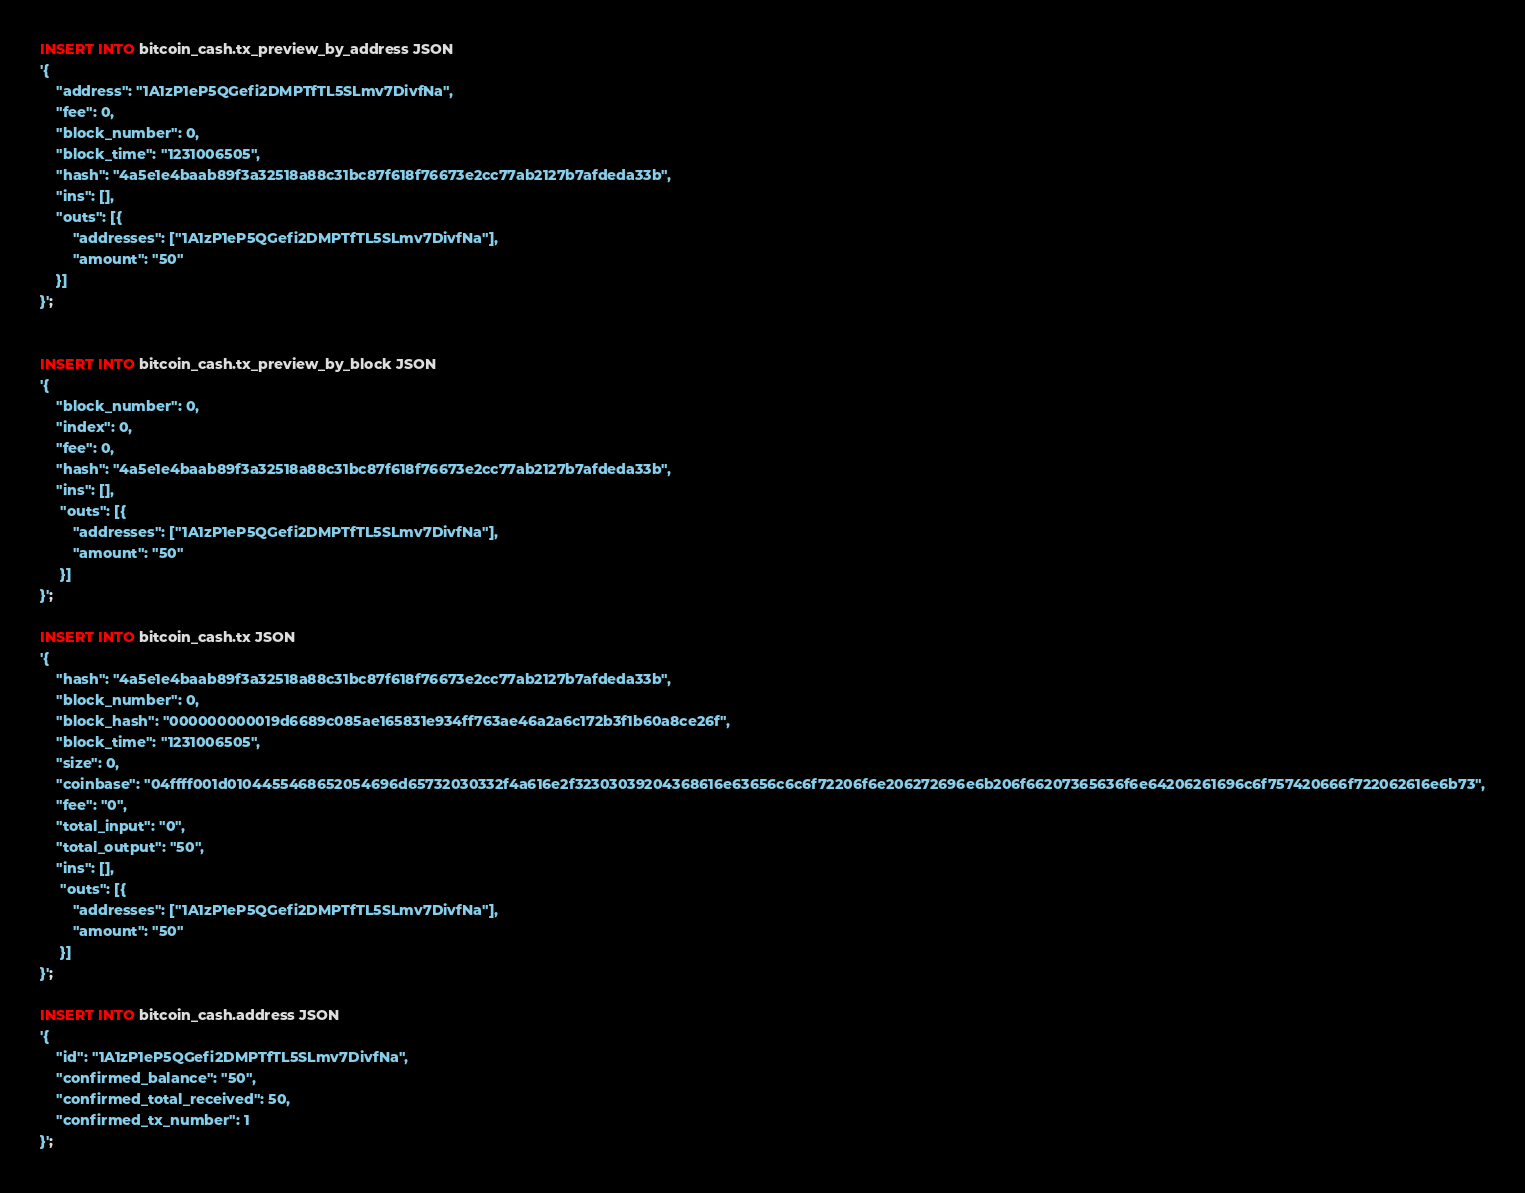Convert code to text. <code><loc_0><loc_0><loc_500><loc_500><_SQL_>INSERT INTO bitcoin_cash.tx_preview_by_address JSON
'{
    "address": "1A1zP1eP5QGefi2DMPTfTL5SLmv7DivfNa",
    "fee": 0,
    "block_number": 0,
    "block_time": "1231006505",
    "hash": "4a5e1e4baab89f3a32518a88c31bc87f618f76673e2cc77ab2127b7afdeda33b",
    "ins": [],
    "outs": [{
        "addresses": ["1A1zP1eP5QGefi2DMPTfTL5SLmv7DivfNa"],
        "amount": "50"
    }]
}';


INSERT INTO bitcoin_cash.tx_preview_by_block JSON
'{
    "block_number": 0,
    "index": 0,
    "fee": 0,
    "hash": "4a5e1e4baab89f3a32518a88c31bc87f618f76673e2cc77ab2127b7afdeda33b",
    "ins": [],
     "outs": [{
        "addresses": ["1A1zP1eP5QGefi2DMPTfTL5SLmv7DivfNa"],
        "amount": "50"
     }]
}';

INSERT INTO bitcoin_cash.tx JSON
'{
    "hash": "4a5e1e4baab89f3a32518a88c31bc87f618f76673e2cc77ab2127b7afdeda33b",
    "block_number": 0,
    "block_hash": "000000000019d6689c085ae165831e934ff763ae46a2a6c172b3f1b60a8ce26f",
    "block_time": "1231006505",
    "size": 0,
    "coinbase": "04ffff001d0104455468652054696d65732030332f4a616e2f32303039204368616e63656c6c6f72206f6e206272696e6b206f66207365636f6e64206261696c6f757420666f722062616e6b73",
    "fee": "0",
    "total_input": "0",
    "total_output": "50",
    "ins": [],
     "outs": [{
        "addresses": ["1A1zP1eP5QGefi2DMPTfTL5SLmv7DivfNa"],
        "amount": "50"
     }]
}';

INSERT INTO bitcoin_cash.address JSON
'{
    "id": "1A1zP1eP5QGefi2DMPTfTL5SLmv7DivfNa",
    "confirmed_balance": "50",
    "confirmed_total_received": 50,
    "confirmed_tx_number": 1
}';</code> 